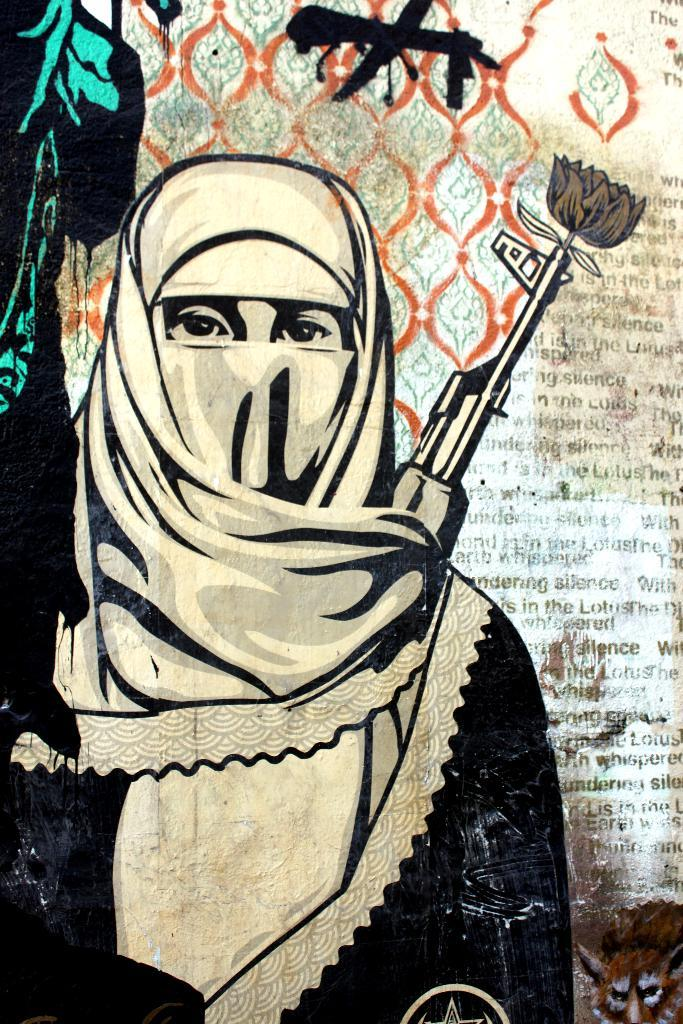What is the main subject of the painting? The painting depicts a woman. What is the woman wearing in the painting? The woman is wearing a white and black colored dress. What objects can be seen in the background of the painting? There is a gun, an animal, a flower, and some writing in the background of the painting. How many thumbs can be seen holding the shelf in the painting? There are no thumbs or shelves present in the painting; it features a woman, a dress, and objects in the background. What type of airplane is flying in the background of the painting? There is no airplane present in the painting; it features a woman, a dress, and objects in the background. 